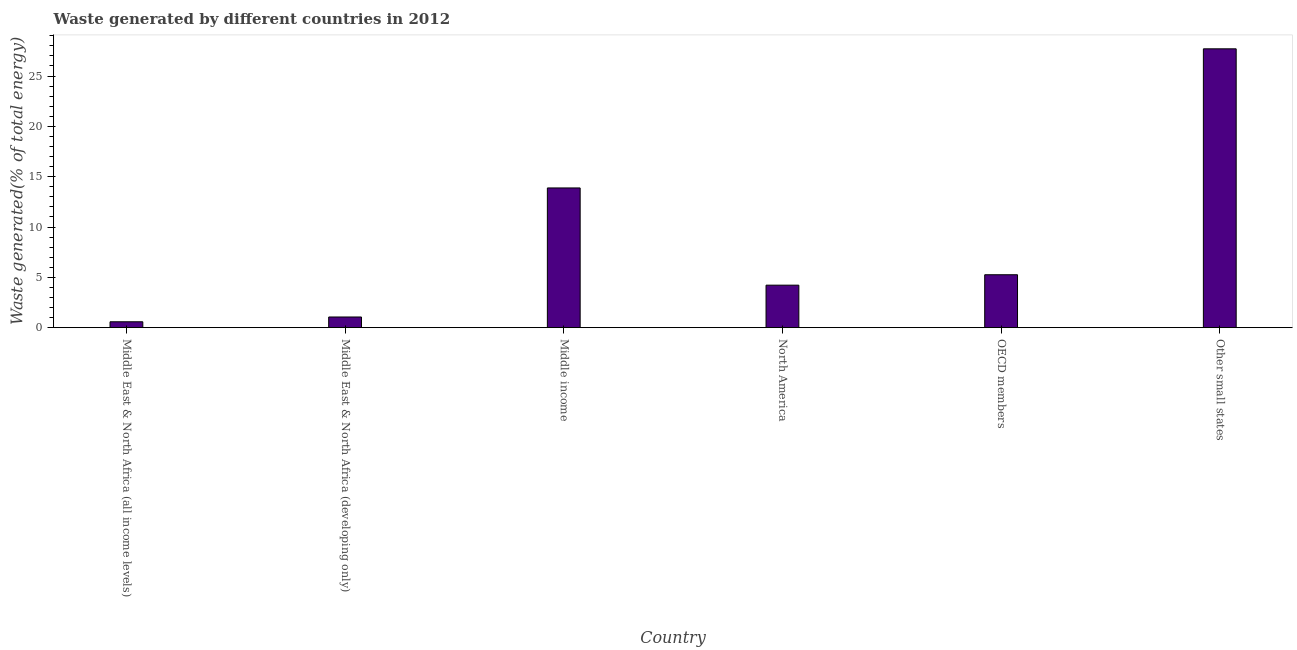Does the graph contain any zero values?
Offer a very short reply. No. Does the graph contain grids?
Offer a terse response. No. What is the title of the graph?
Your response must be concise. Waste generated by different countries in 2012. What is the label or title of the Y-axis?
Your answer should be very brief. Waste generated(% of total energy). What is the amount of waste generated in Middle East & North Africa (all income levels)?
Ensure brevity in your answer.  0.58. Across all countries, what is the maximum amount of waste generated?
Keep it short and to the point. 27.71. Across all countries, what is the minimum amount of waste generated?
Your answer should be very brief. 0.58. In which country was the amount of waste generated maximum?
Give a very brief answer. Other small states. In which country was the amount of waste generated minimum?
Provide a succinct answer. Middle East & North Africa (all income levels). What is the sum of the amount of waste generated?
Offer a terse response. 52.72. What is the difference between the amount of waste generated in Middle income and OECD members?
Make the answer very short. 8.62. What is the average amount of waste generated per country?
Provide a short and direct response. 8.79. What is the median amount of waste generated?
Ensure brevity in your answer.  4.74. In how many countries, is the amount of waste generated greater than 3 %?
Your response must be concise. 4. What is the ratio of the amount of waste generated in Middle East & North Africa (developing only) to that in Middle income?
Offer a very short reply. 0.08. Is the difference between the amount of waste generated in Middle East & North Africa (developing only) and North America greater than the difference between any two countries?
Provide a short and direct response. No. What is the difference between the highest and the second highest amount of waste generated?
Your response must be concise. 13.82. Is the sum of the amount of waste generated in OECD members and Other small states greater than the maximum amount of waste generated across all countries?
Give a very brief answer. Yes. What is the difference between the highest and the lowest amount of waste generated?
Your answer should be compact. 27.12. In how many countries, is the amount of waste generated greater than the average amount of waste generated taken over all countries?
Keep it short and to the point. 2. Are the values on the major ticks of Y-axis written in scientific E-notation?
Offer a very short reply. No. What is the Waste generated(% of total energy) of Middle East & North Africa (all income levels)?
Keep it short and to the point. 0.58. What is the Waste generated(% of total energy) in Middle East & North Africa (developing only)?
Make the answer very short. 1.06. What is the Waste generated(% of total energy) of Middle income?
Provide a succinct answer. 13.88. What is the Waste generated(% of total energy) of North America?
Give a very brief answer. 4.22. What is the Waste generated(% of total energy) of OECD members?
Ensure brevity in your answer.  5.26. What is the Waste generated(% of total energy) in Other small states?
Provide a short and direct response. 27.71. What is the difference between the Waste generated(% of total energy) in Middle East & North Africa (all income levels) and Middle East & North Africa (developing only)?
Make the answer very short. -0.48. What is the difference between the Waste generated(% of total energy) in Middle East & North Africa (all income levels) and Middle income?
Keep it short and to the point. -13.3. What is the difference between the Waste generated(% of total energy) in Middle East & North Africa (all income levels) and North America?
Your answer should be very brief. -3.64. What is the difference between the Waste generated(% of total energy) in Middle East & North Africa (all income levels) and OECD members?
Ensure brevity in your answer.  -4.67. What is the difference between the Waste generated(% of total energy) in Middle East & North Africa (all income levels) and Other small states?
Ensure brevity in your answer.  -27.12. What is the difference between the Waste generated(% of total energy) in Middle East & North Africa (developing only) and Middle income?
Your answer should be very brief. -12.82. What is the difference between the Waste generated(% of total energy) in Middle East & North Africa (developing only) and North America?
Your answer should be very brief. -3.16. What is the difference between the Waste generated(% of total energy) in Middle East & North Africa (developing only) and OECD members?
Give a very brief answer. -4.2. What is the difference between the Waste generated(% of total energy) in Middle East & North Africa (developing only) and Other small states?
Your answer should be compact. -26.64. What is the difference between the Waste generated(% of total energy) in Middle income and North America?
Make the answer very short. 9.66. What is the difference between the Waste generated(% of total energy) in Middle income and OECD members?
Provide a short and direct response. 8.63. What is the difference between the Waste generated(% of total energy) in Middle income and Other small states?
Offer a very short reply. -13.82. What is the difference between the Waste generated(% of total energy) in North America and OECD members?
Provide a short and direct response. -1.03. What is the difference between the Waste generated(% of total energy) in North America and Other small states?
Provide a short and direct response. -23.48. What is the difference between the Waste generated(% of total energy) in OECD members and Other small states?
Ensure brevity in your answer.  -22.45. What is the ratio of the Waste generated(% of total energy) in Middle East & North Africa (all income levels) to that in Middle East & North Africa (developing only)?
Keep it short and to the point. 0.55. What is the ratio of the Waste generated(% of total energy) in Middle East & North Africa (all income levels) to that in Middle income?
Give a very brief answer. 0.04. What is the ratio of the Waste generated(% of total energy) in Middle East & North Africa (all income levels) to that in North America?
Ensure brevity in your answer.  0.14. What is the ratio of the Waste generated(% of total energy) in Middle East & North Africa (all income levels) to that in OECD members?
Ensure brevity in your answer.  0.11. What is the ratio of the Waste generated(% of total energy) in Middle East & North Africa (all income levels) to that in Other small states?
Your response must be concise. 0.02. What is the ratio of the Waste generated(% of total energy) in Middle East & North Africa (developing only) to that in Middle income?
Ensure brevity in your answer.  0.08. What is the ratio of the Waste generated(% of total energy) in Middle East & North Africa (developing only) to that in North America?
Provide a succinct answer. 0.25. What is the ratio of the Waste generated(% of total energy) in Middle East & North Africa (developing only) to that in OECD members?
Make the answer very short. 0.2. What is the ratio of the Waste generated(% of total energy) in Middle East & North Africa (developing only) to that in Other small states?
Make the answer very short. 0.04. What is the ratio of the Waste generated(% of total energy) in Middle income to that in North America?
Offer a very short reply. 3.29. What is the ratio of the Waste generated(% of total energy) in Middle income to that in OECD members?
Your answer should be very brief. 2.64. What is the ratio of the Waste generated(% of total energy) in Middle income to that in Other small states?
Give a very brief answer. 0.5. What is the ratio of the Waste generated(% of total energy) in North America to that in OECD members?
Give a very brief answer. 0.8. What is the ratio of the Waste generated(% of total energy) in North America to that in Other small states?
Ensure brevity in your answer.  0.15. What is the ratio of the Waste generated(% of total energy) in OECD members to that in Other small states?
Make the answer very short. 0.19. 